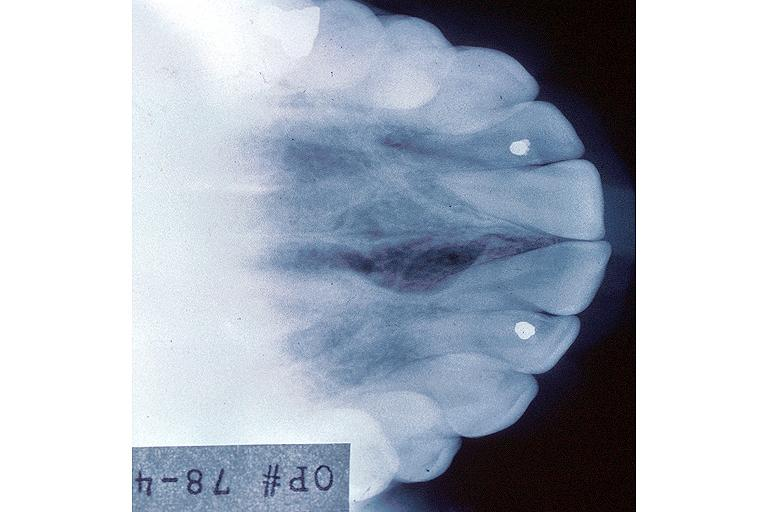what is present?
Answer the question using a single word or phrase. Oral 